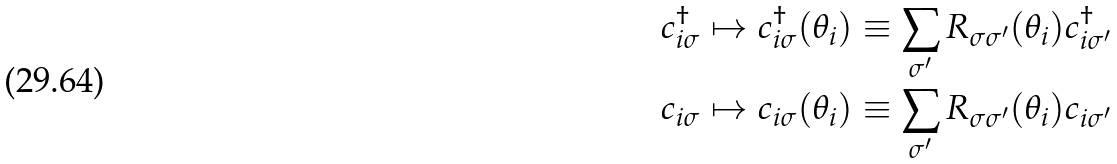Convert formula to latex. <formula><loc_0><loc_0><loc_500><loc_500>& c _ { i \sigma } ^ { \dag } \mapsto c _ { i \sigma } ^ { \dag } ( \theta _ { i } ) \equiv \sum _ { \sigma ^ { \prime } } R _ { \sigma \sigma ^ { \prime } } ( \theta _ { i } ) c _ { i \sigma ^ { \prime } } ^ { \dag } \\ & c _ { i \sigma } \mapsto c _ { i \sigma } ( \theta _ { i } ) \equiv \sum _ { \sigma ^ { \prime } } R _ { \sigma \sigma ^ { \prime } } ( \theta _ { i } ) c _ { i \sigma ^ { \prime } }</formula> 